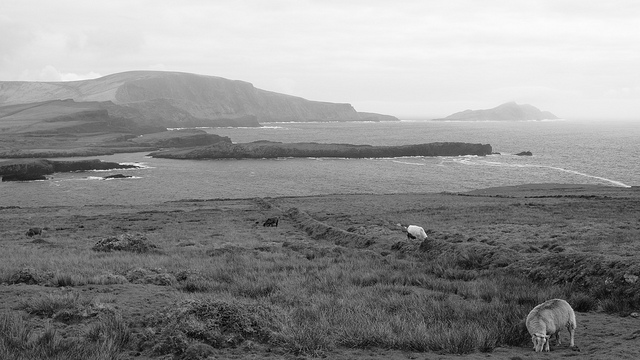<image>What color is the dog? There is no dog in the image. What color is the dog? The dog in the image is white. 